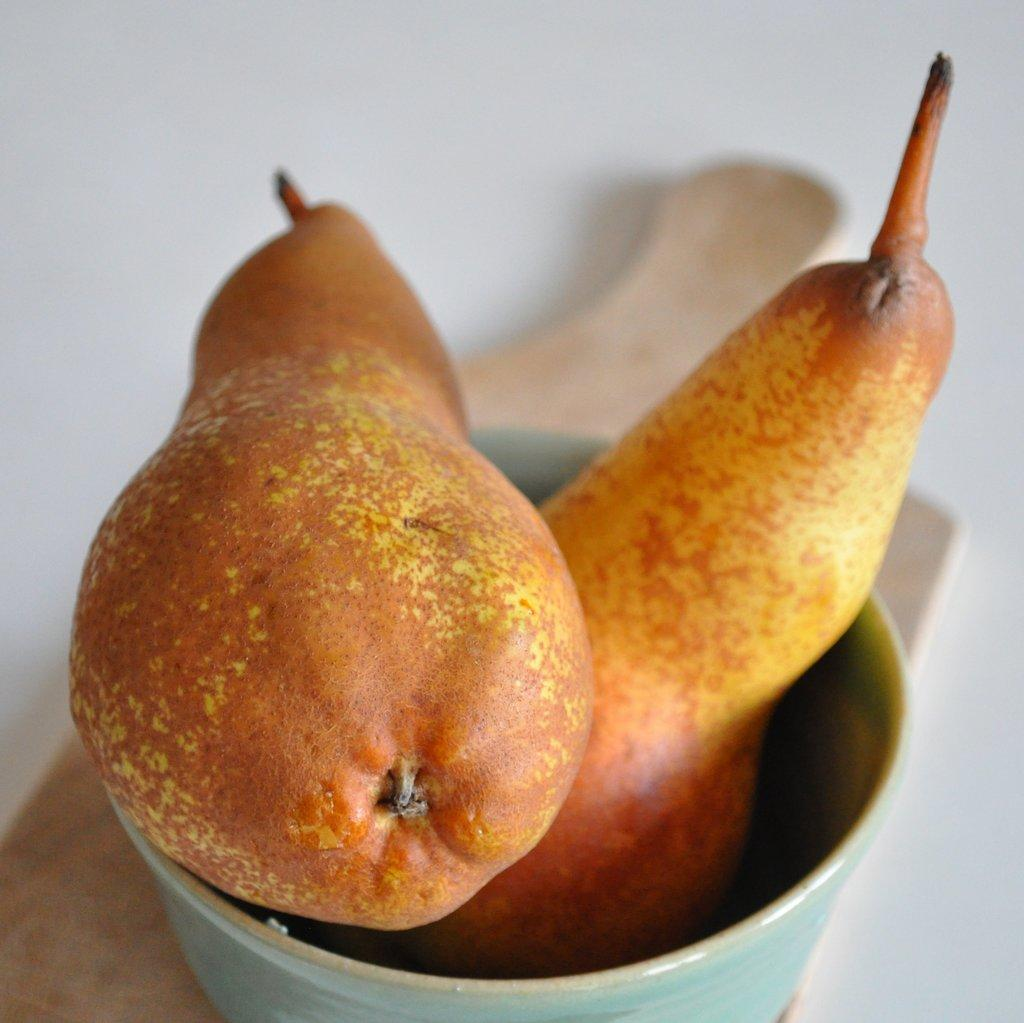What is in the bowl that is visible in the image? There are fruits in a bowl in the image. What colors can be seen on the fruits in the image? The fruits have yellow, brown, and orange colors. What is the color of the background in the image? The background of the image is white. Can you tell me how many minutes it takes for the donkey to eat the banana in the image? There is no donkey or banana present in the image, so it is not possible to answer that question. 